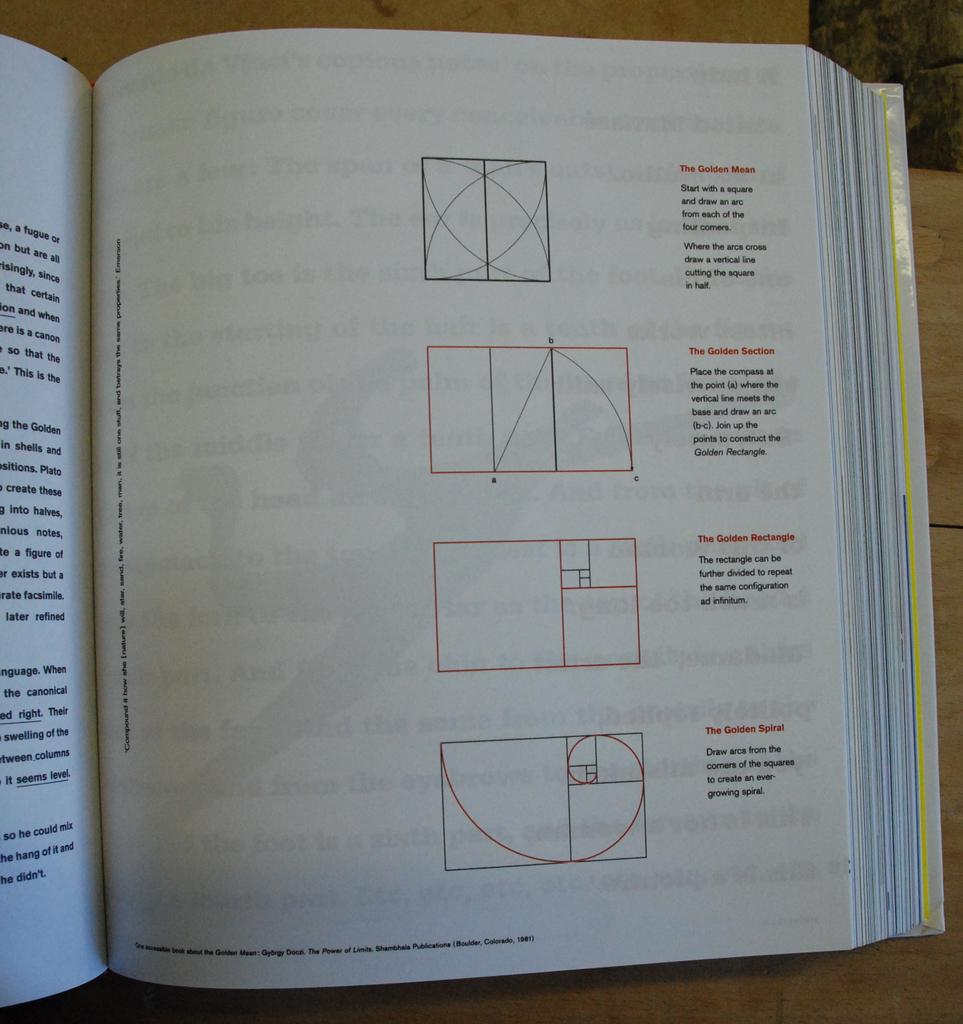<image>
Relay a brief, clear account of the picture shown. A book is open to a page dealing with The Golden Mean, The Golden Section, The Golden Rectangle, and The Golden Spiral., and 